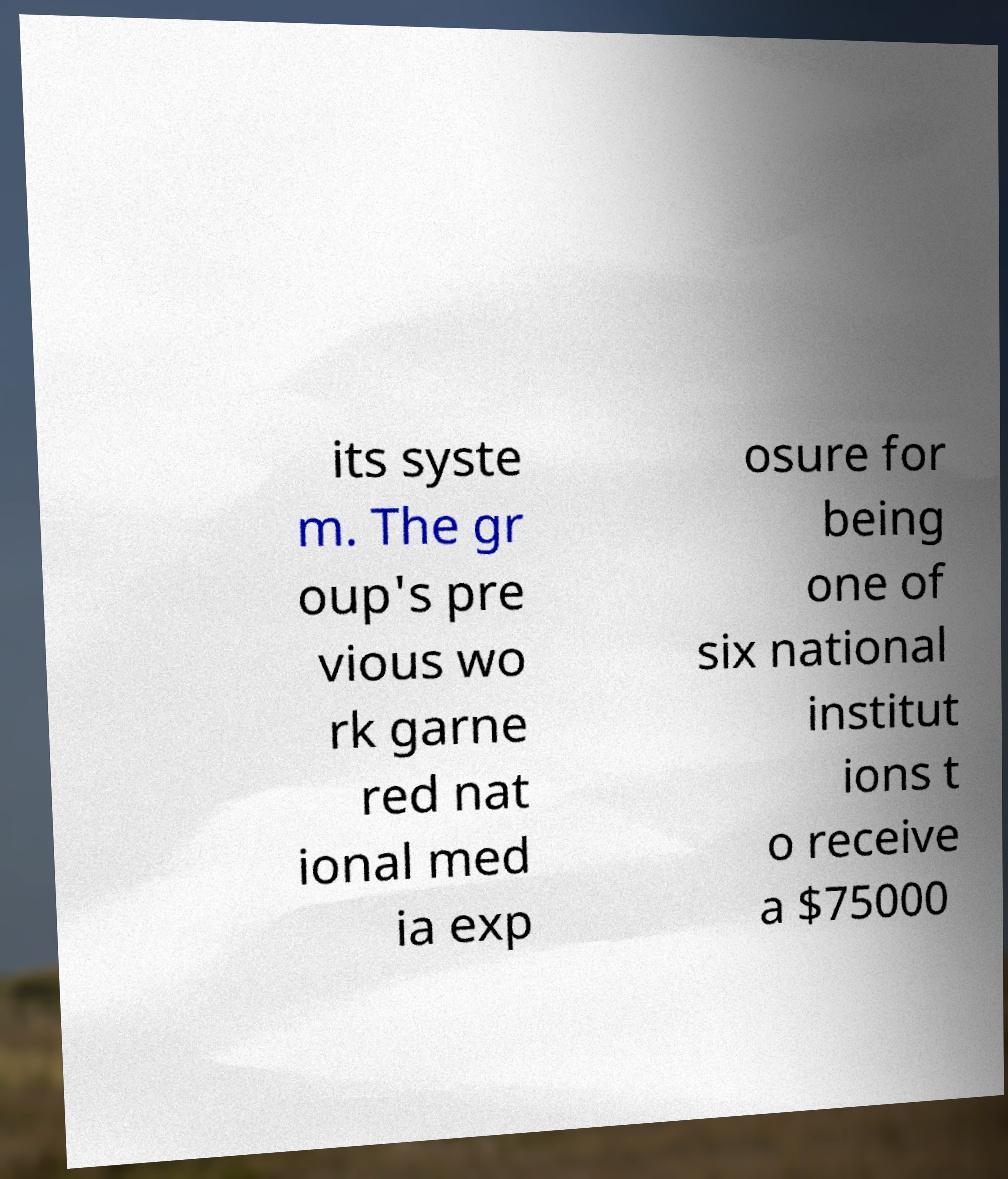I need the written content from this picture converted into text. Can you do that? its syste m. The gr oup's pre vious wo rk garne red nat ional med ia exp osure for being one of six national institut ions t o receive a $75000 